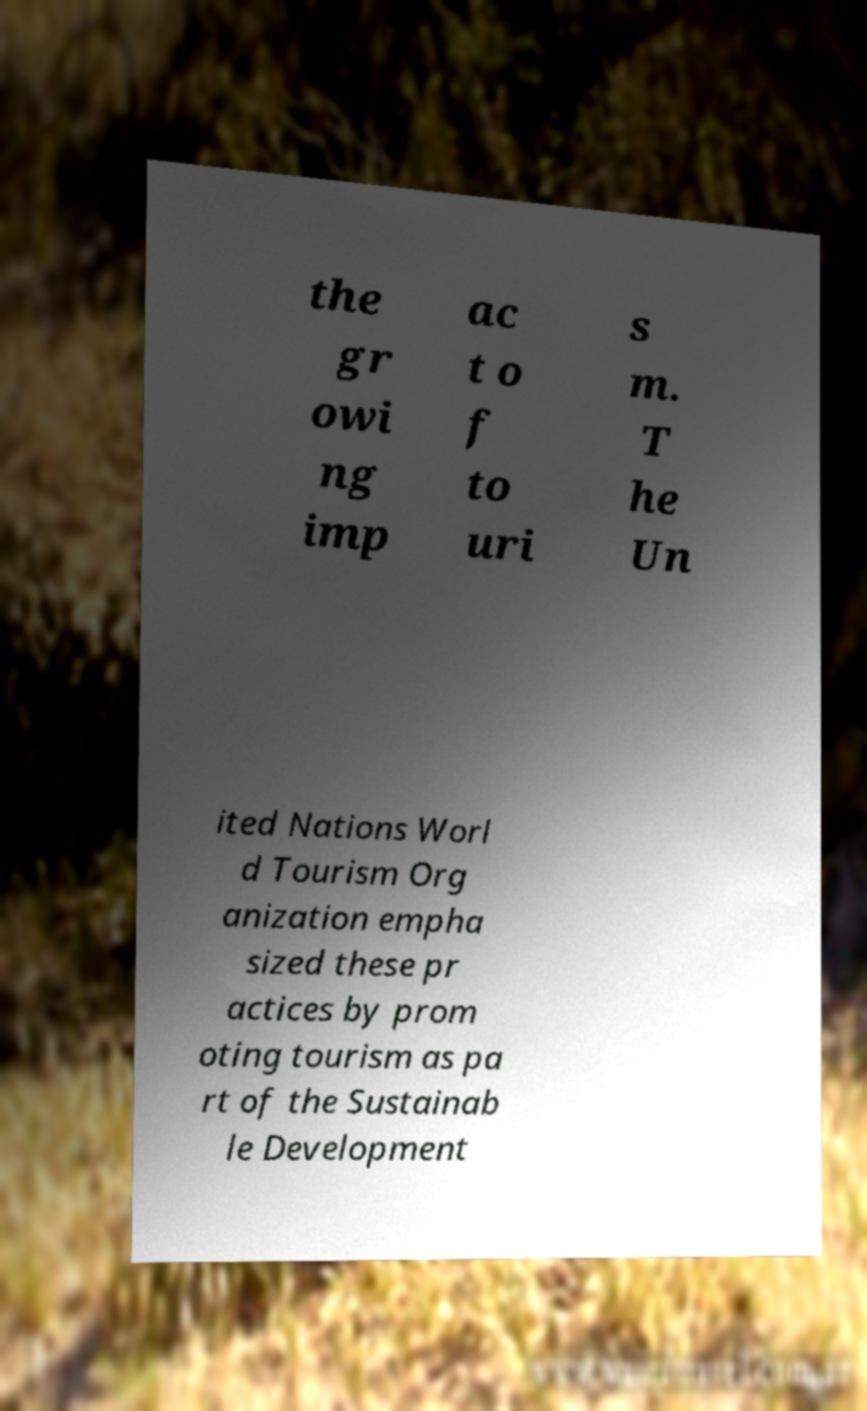There's text embedded in this image that I need extracted. Can you transcribe it verbatim? the gr owi ng imp ac t o f to uri s m. T he Un ited Nations Worl d Tourism Org anization empha sized these pr actices by prom oting tourism as pa rt of the Sustainab le Development 